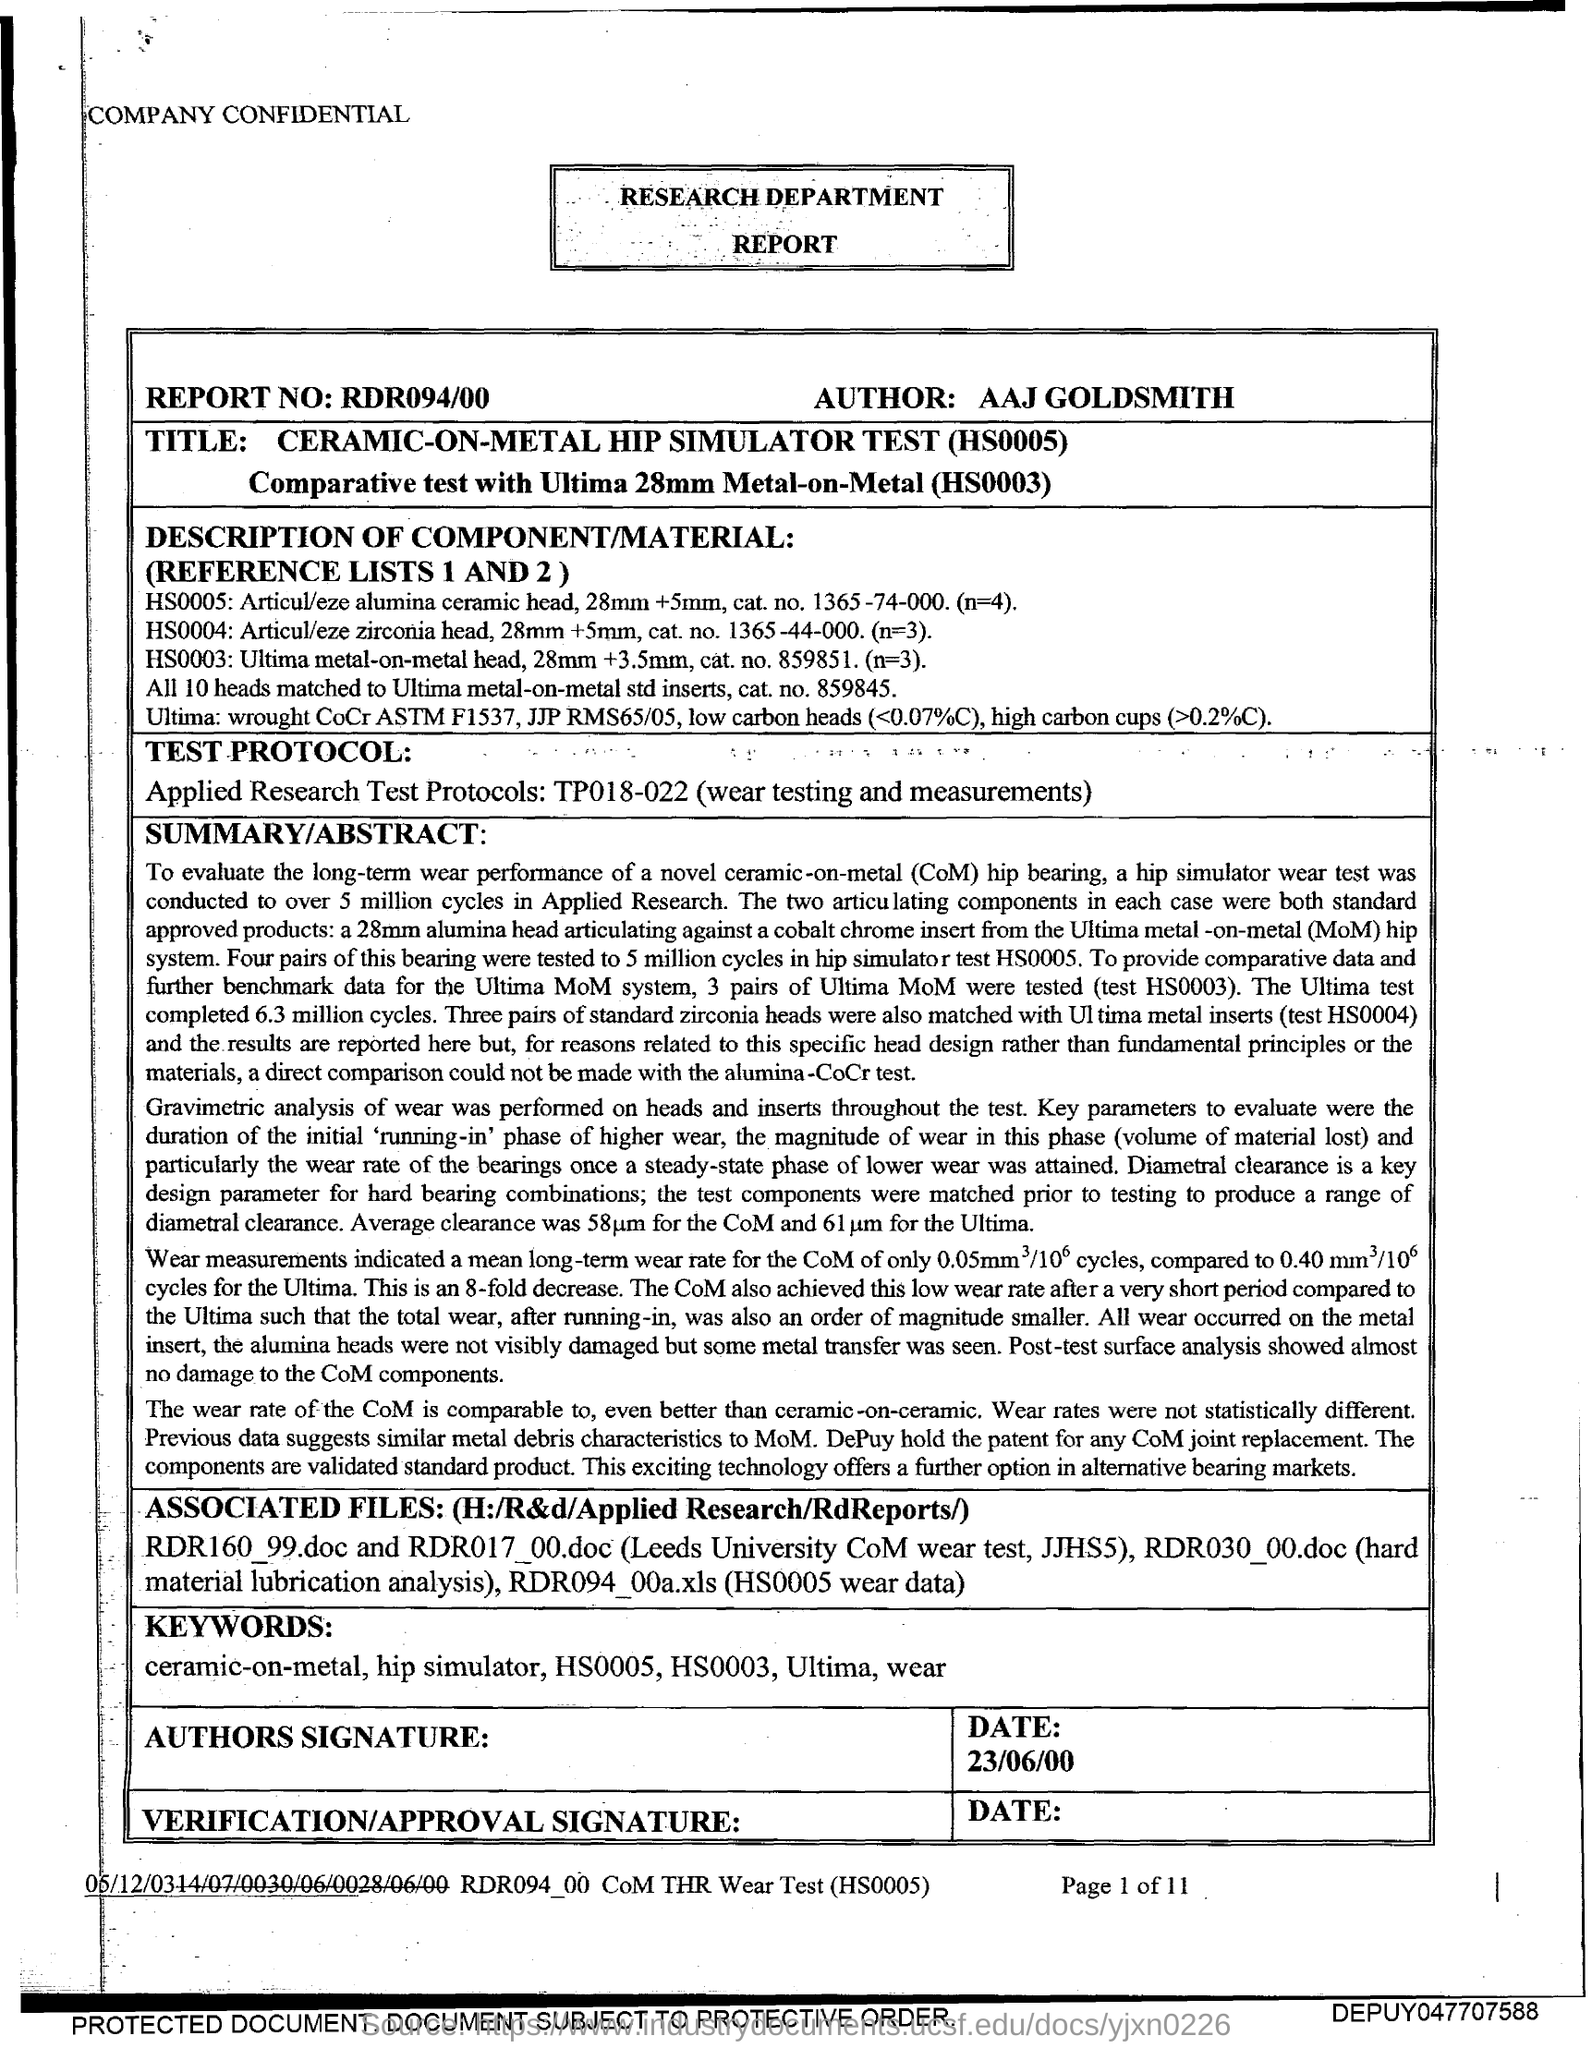Identify some key points in this picture. The date mentioned in this report is 23rd June 2000. The report number mentioned is RDR094/00. 